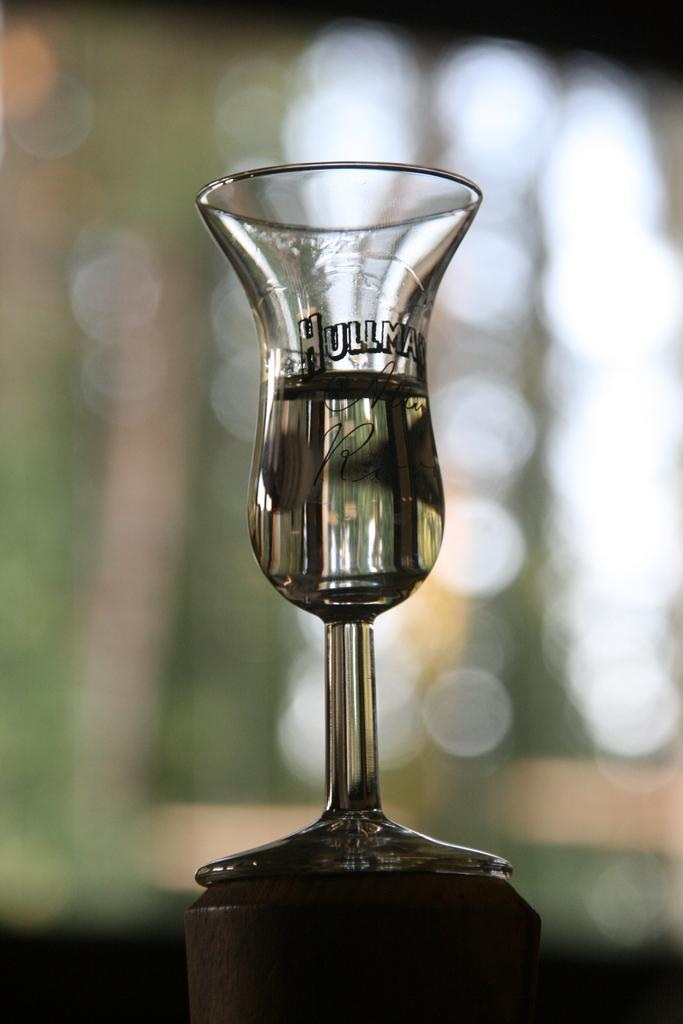What object can be seen in the picture? There is a glass in the picture. What is unique about the glass? The glass has something written on it. How would you describe the background of the image? The background of the image is blurred. What is the weight of the roll in the image? There is no roll present in the image, so it is not possible to determine its weight. 